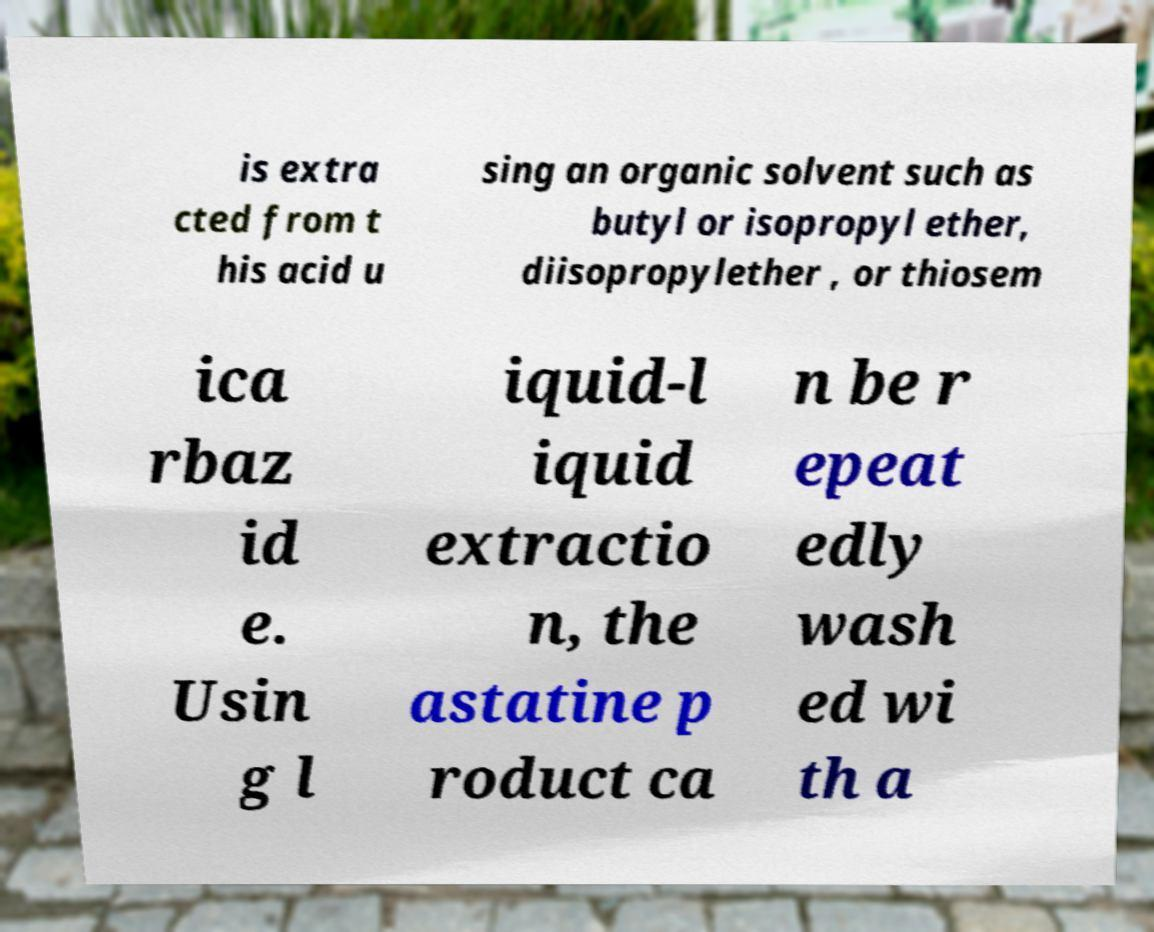I need the written content from this picture converted into text. Can you do that? is extra cted from t his acid u sing an organic solvent such as butyl or isopropyl ether, diisopropylether , or thiosem ica rbaz id e. Usin g l iquid-l iquid extractio n, the astatine p roduct ca n be r epeat edly wash ed wi th a 